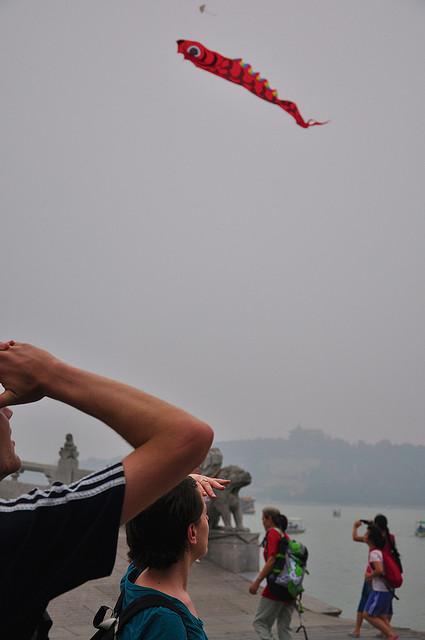Is it a sunny day?
Concise answer only. No. What is the orange object called?
Quick response, please. Kite. Does the person in the red shirt have a backpack on?
Short answer required. Yes. What is the kite supposed to be?
Quick response, please. Fish. 